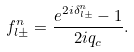<formula> <loc_0><loc_0><loc_500><loc_500>f _ { l \pm } ^ { n } = \frac { e ^ { 2 i \delta _ { l \pm } ^ { n } } - 1 } { 2 i q _ { c } } .</formula> 